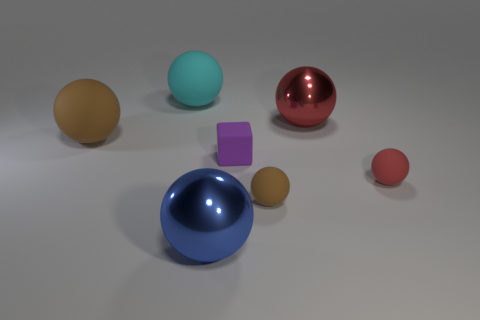Subtract all red balls. How many balls are left? 4 Subtract all small brown matte balls. How many balls are left? 5 Add 2 tiny matte objects. How many objects exist? 9 Subtract all cyan spheres. Subtract all gray cylinders. How many spheres are left? 5 Subtract all blocks. How many objects are left? 6 Subtract all brown metal balls. Subtract all big blue shiny balls. How many objects are left? 6 Add 7 red objects. How many red objects are left? 9 Add 7 large gray shiny blocks. How many large gray shiny blocks exist? 7 Subtract 0 purple spheres. How many objects are left? 7 